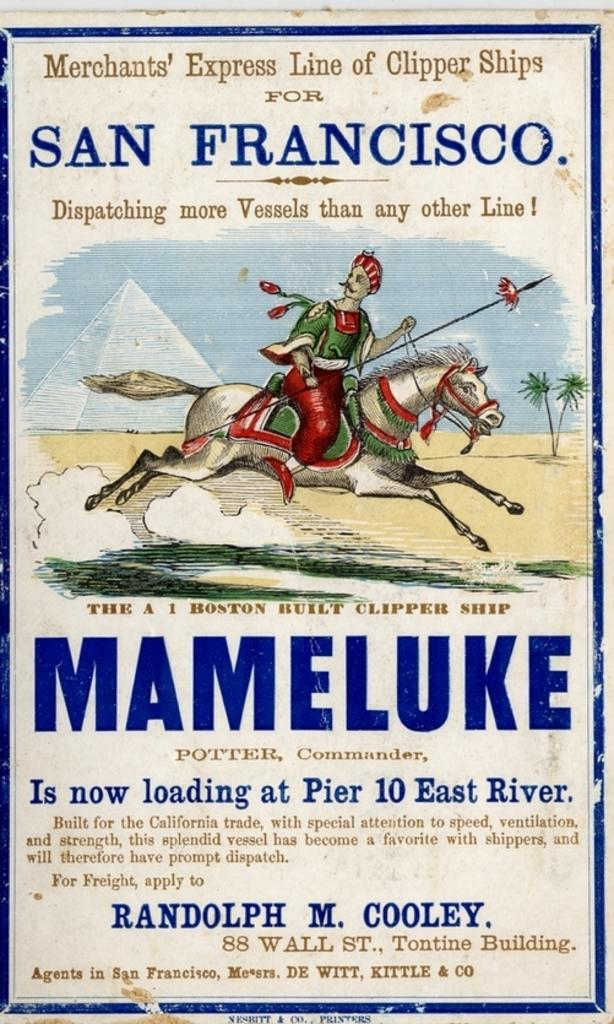What type of artwork is shown in the image? The image is of a painting. What subjects are depicted in the painting? The painting depicts a person, a horse, a mountain, and trees. Can you describe the setting of the painting? The painting depicts a person and a horse in front of a mountain, with trees in the background. Is there any text visible in the image? Yes, there is text visible in the background of the image. How much money is being exchanged between the person and the horse in the painting? There is no exchange of money depicted in the painting; it shows a person and a horse in front of a mountain, with trees in the background. 